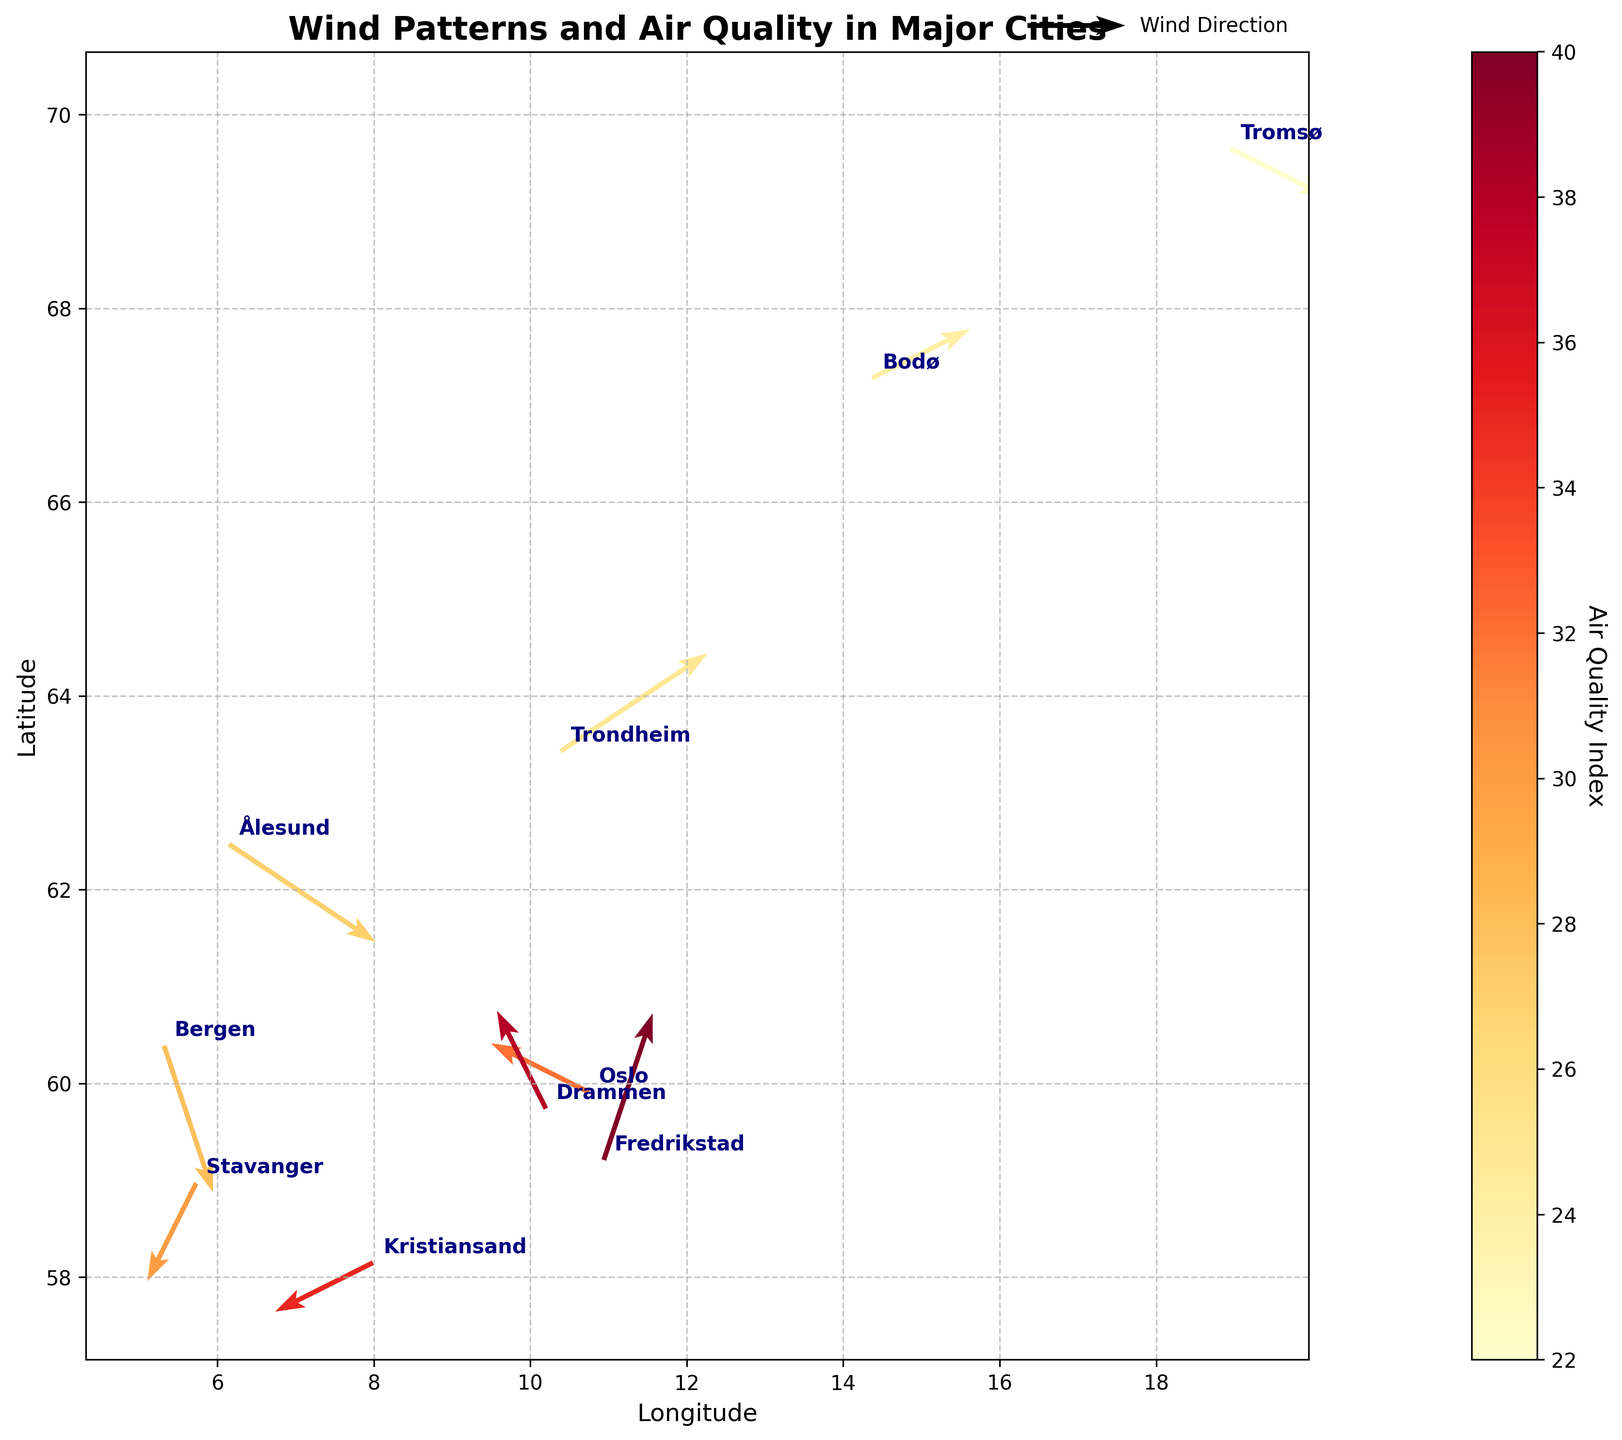What's the title of the figure? The title of the figure is clearly indicated at the top of the plot. It summarizes the main focus of the plot content.
Answer: Wind Patterns and Air Quality in Major Cities How many cities are represented in the figure? Each city is represented by its location marked and annotated on the plot. Counting the annotations, we see there are 10 cities.
Answer: 10 What city has the highest Air Quality Index (AQI)? By observing the color intensity and referring to the color bar, the city with the darkest shade corresponds to the highest AQI. Here, Fredrikstad shows the highest value.
Answer: Fredrikstad What is the AQI range represented in the figure? By examining the color bar legend, we can determine the lowest and highest values for AQI, which in this case range from 22 to 40.
Answer: 22 to 40 Which city has the strongest wind speed based on the arrow length? The lengths of the arrows signify the magnitude of wind speed. Trondheim has the longest arrow, suggesting the strongest wind speed.
Answer: Trondheim Which cities experience northward wind directions? Cities with arrows pointing mostly upwards (positive Y direction) indicate northward wind. Oslo, Drammen, and Fredrikstad show this pattern.
Answer: Oslo, Drammen, Fredrikstad What is the average AQI of cities with negative X wind direction? Identify cities with negative X wind direction: Oslo, Stavanger, Kristiansand, and Drammen. Their AQIs are 32, 30, 35, and 38, respectively. The average is (32 + 30 + 35 + 38) / 4 = 33.75
Answer: 33.75 Which city has the largest angle deviation from the x-axis in wind direction? The city with the arrow at the steepest angle deviates the most from the x-axis. By visual inspection, Bergen’s arrow, pointing almost vertically downward, has the largest deviation.
Answer: Bergen Do cities with higher AQI generally experience stronger wind? Compare the arrow lengths and corresponding AQI values. For example, Trondheim has a long arrow but low AQI, while Fredrikstad has a high AQI but a short arrow, suggesting no direct correlation.
Answer: No What is the latitudinal range covered by the cities? Find the cities with the highest and lowest latitudes on the y-axis. Tromsø (69.65) and Kristiansand (58.15) offer the range. The latitudinal range is 69.65 - 58.15.
Answer: 11.5 degrees 